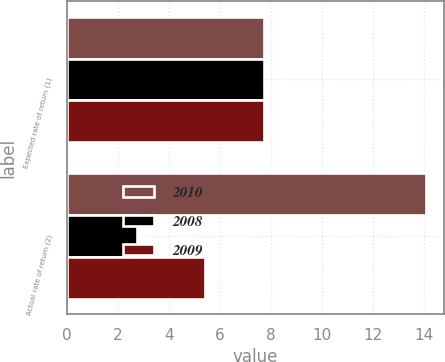Convert chart to OTSL. <chart><loc_0><loc_0><loc_500><loc_500><stacked_bar_chart><ecel><fcel>Expected rate of return (1)<fcel>Actual rate of return (2)<nl><fcel>2010<fcel>7.75<fcel>14.11<nl><fcel>2008<fcel>7.75<fcel>2.77<nl><fcel>2009<fcel>7.75<fcel>5.42<nl></chart> 